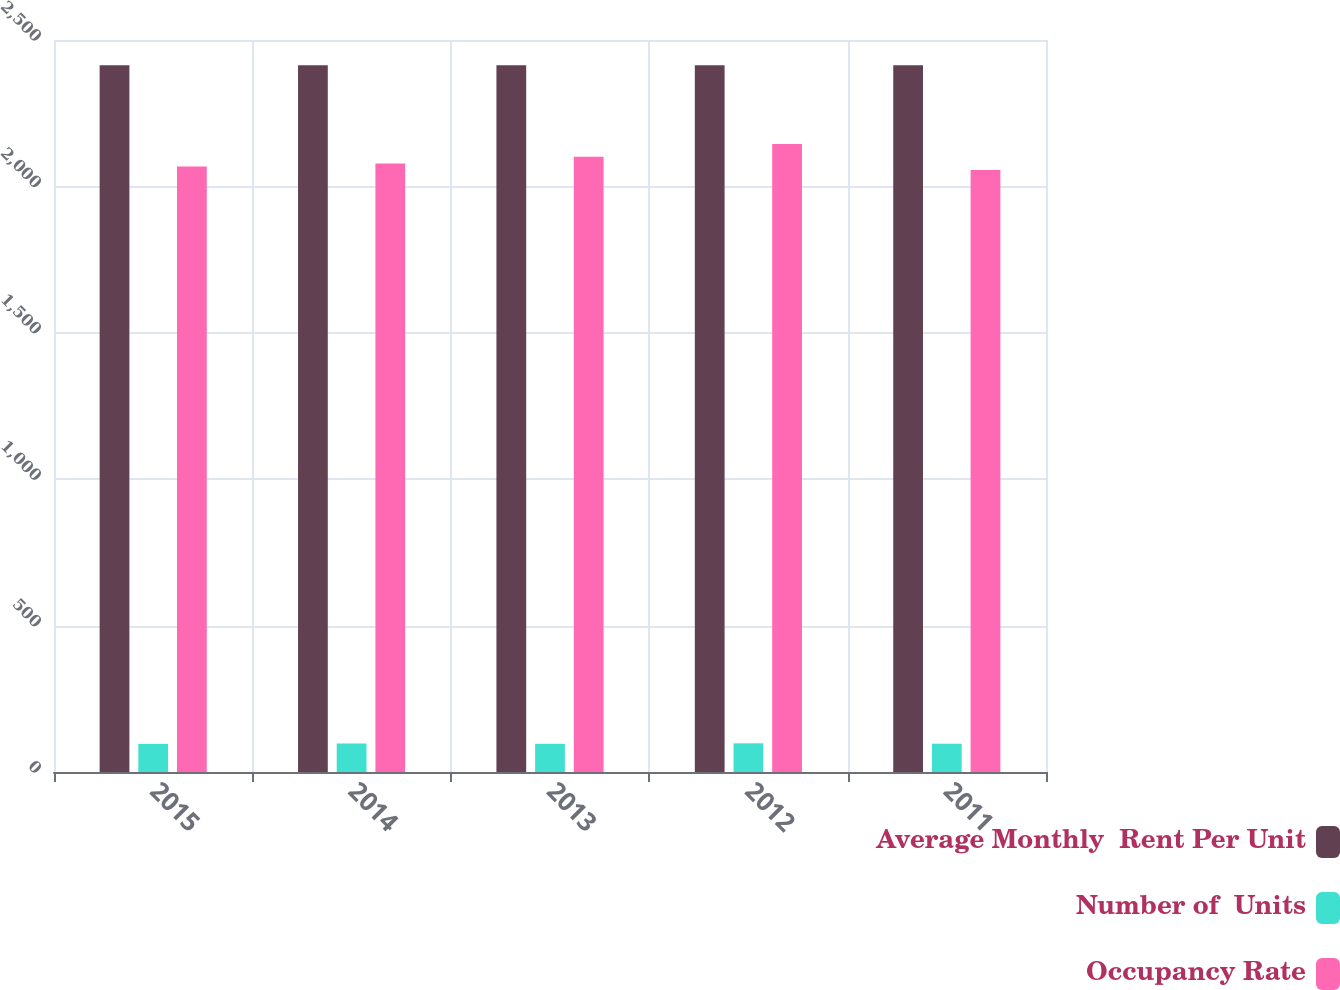Convert chart. <chart><loc_0><loc_0><loc_500><loc_500><stacked_bar_chart><ecel><fcel>2015<fcel>2014<fcel>2013<fcel>2012<fcel>2011<nl><fcel>Average Monthly  Rent Per Unit<fcel>2414<fcel>2414<fcel>2414<fcel>2414<fcel>2414<nl><fcel>Number of  Units<fcel>96.1<fcel>97.4<fcel>96.3<fcel>97.9<fcel>96.6<nl><fcel>Occupancy Rate<fcel>2068<fcel>2078<fcel>2101<fcel>2145<fcel>2056<nl></chart> 